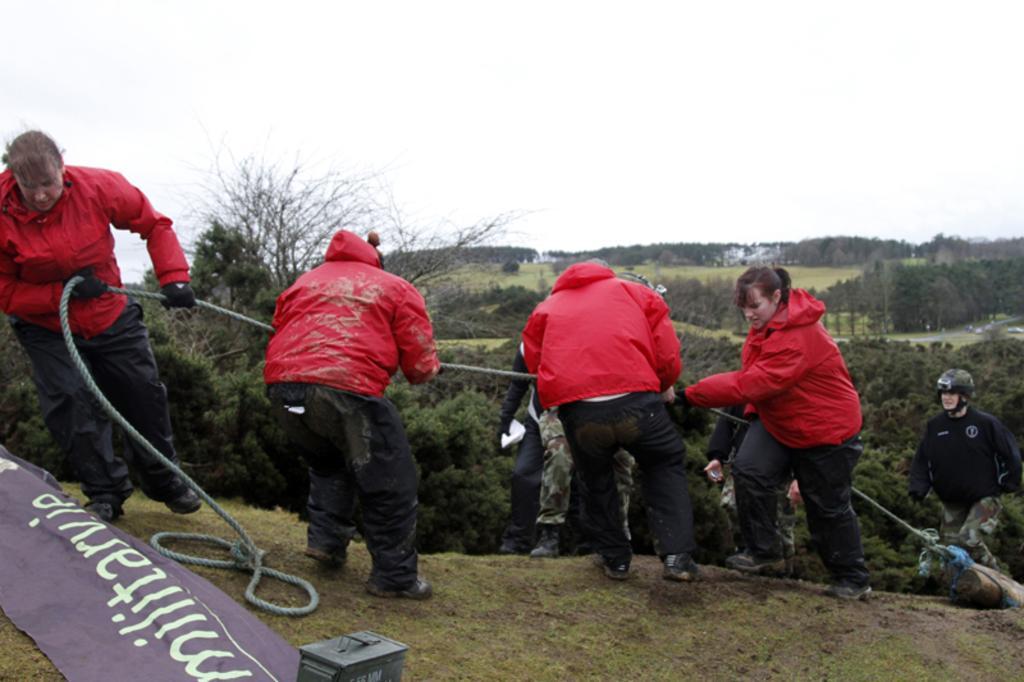In one or two sentences, can you explain what this image depicts? In this image we can see people are holding a rope. In the background, we can see trees and grassy land. At the top of the image, we can see the sky. At the bottom of the image, we can see land, banner, wood and a metal object. 